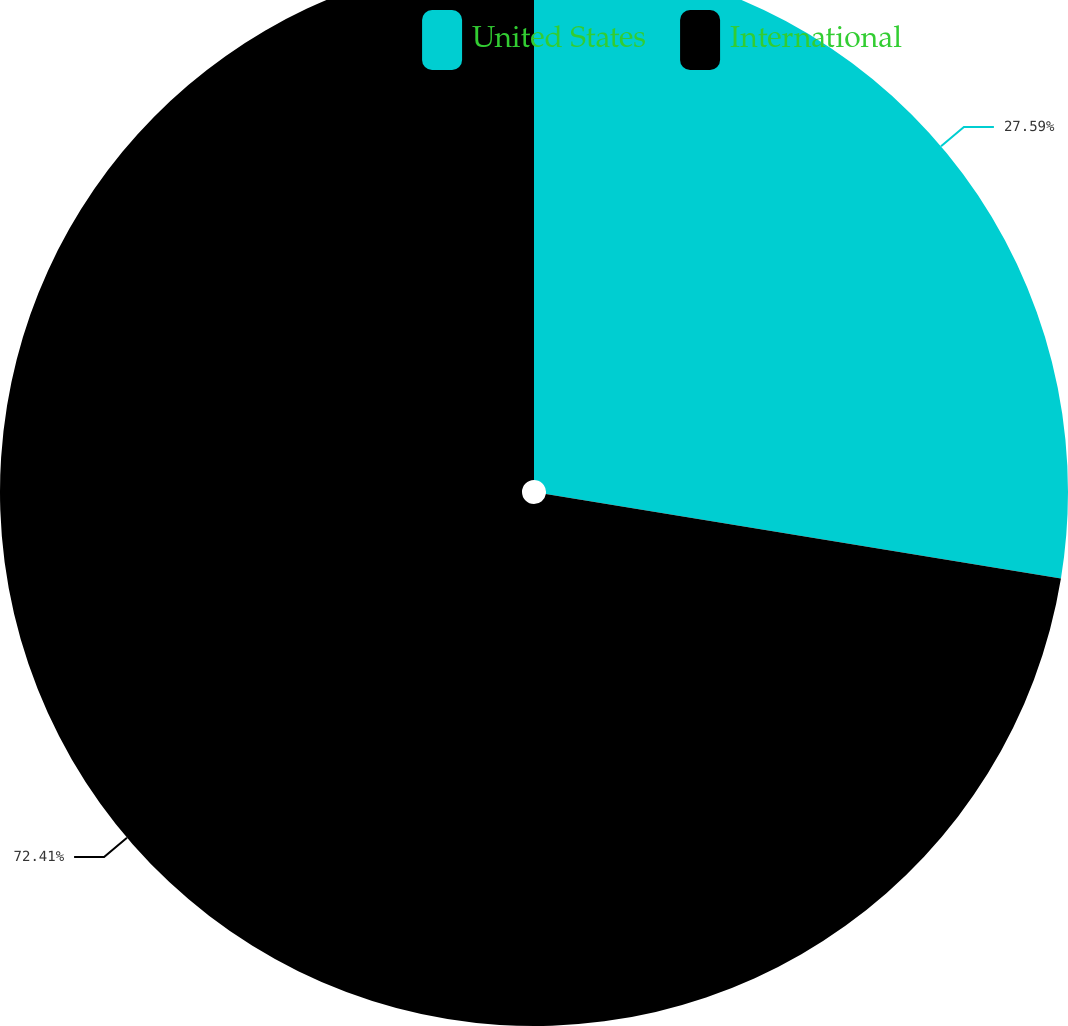<chart> <loc_0><loc_0><loc_500><loc_500><pie_chart><fcel>United States<fcel>International<nl><fcel>27.59%<fcel>72.41%<nl></chart> 